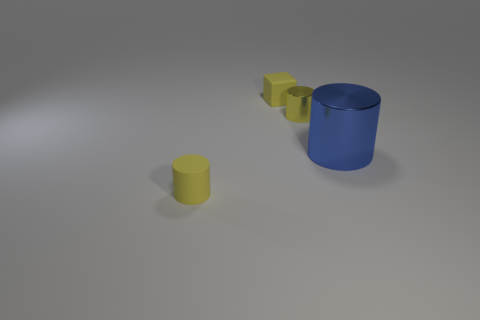Is there any other thing that is the same size as the blue cylinder?
Provide a short and direct response. No. Are there an equal number of tiny yellow objects in front of the cube and small cylinders to the left of the large metal object?
Offer a very short reply. Yes. Is there anything else that is made of the same material as the yellow cube?
Make the answer very short. Yes. There is a yellow cube; does it have the same size as the blue cylinder on the right side of the small yellow cube?
Keep it short and to the point. No. What is the material of the small cylinder behind the tiny yellow object in front of the big shiny thing?
Provide a succinct answer. Metal. Are there the same number of yellow cubes in front of the yellow rubber cylinder and tiny green spheres?
Your answer should be compact. Yes. There is a cylinder that is in front of the yellow metallic cylinder and behind the tiny matte cylinder; what is its size?
Ensure brevity in your answer.  Large. What color is the cylinder on the right side of the tiny yellow cylinder that is behind the blue thing?
Your answer should be very brief. Blue. How many yellow things are matte cylinders or cylinders?
Your answer should be very brief. 2. There is a tiny object that is in front of the small matte block and on the left side of the small metallic cylinder; what color is it?
Keep it short and to the point. Yellow. 